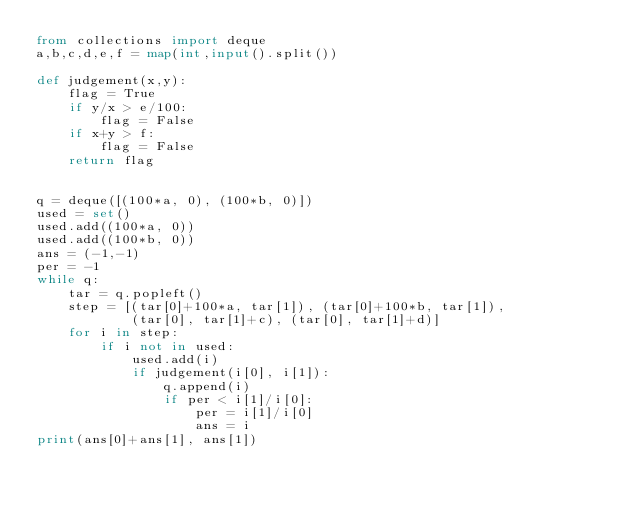<code> <loc_0><loc_0><loc_500><loc_500><_Python_>from collections import deque
a,b,c,d,e,f = map(int,input().split())

def judgement(x,y):
    flag = True
    if y/x > e/100:
        flag = False
    if x+y > f:
        flag = False
    return flag


q = deque([(100*a, 0), (100*b, 0)])
used = set()
used.add((100*a, 0))
used.add((100*b, 0))
ans = (-1,-1)
per = -1
while q:
    tar = q.popleft()
    step = [(tar[0]+100*a, tar[1]), (tar[0]+100*b, tar[1]),
            (tar[0], tar[1]+c), (tar[0], tar[1]+d)]
    for i in step:
        if i not in used:
            used.add(i)
            if judgement(i[0], i[1]):
                q.append(i)
                if per < i[1]/i[0]:
                    per = i[1]/i[0]
                    ans = i
print(ans[0]+ans[1], ans[1])





</code> 